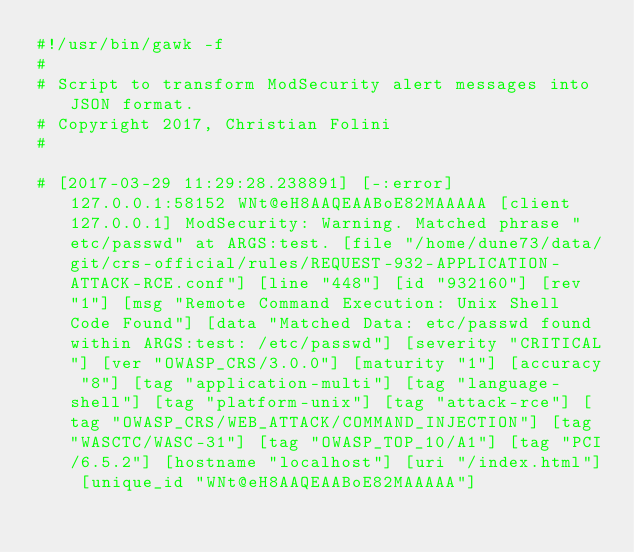<code> <loc_0><loc_0><loc_500><loc_500><_Awk_>#!/usr/bin/gawk -f
#
# Script to transform ModSecurity alert messages into JSON format.
# Copyright 2017, Christian Folini
#

# [2017-03-29 11:29:28.238891] [-:error] 127.0.0.1:58152 WNt@eH8AAQEAABoE82MAAAAA [client 127.0.0.1] ModSecurity: Warning. Matched phrase "etc/passwd" at ARGS:test. [file "/home/dune73/data/git/crs-official/rules/REQUEST-932-APPLICATION-ATTACK-RCE.conf"] [line "448"] [id "932160"] [rev "1"] [msg "Remote Command Execution: Unix Shell Code Found"] [data "Matched Data: etc/passwd found within ARGS:test: /etc/passwd"] [severity "CRITICAL"] [ver "OWASP_CRS/3.0.0"] [maturity "1"] [accuracy "8"] [tag "application-multi"] [tag "language-shell"] [tag "platform-unix"] [tag "attack-rce"] [tag "OWASP_CRS/WEB_ATTACK/COMMAND_INJECTION"] [tag "WASCTC/WASC-31"] [tag "OWASP_TOP_10/A1"] [tag "PCI/6.5.2"] [hostname "localhost"] [uri "/index.html"] [unique_id "WNt@eH8AAQEAABoE82MAAAAA"]
</code> 